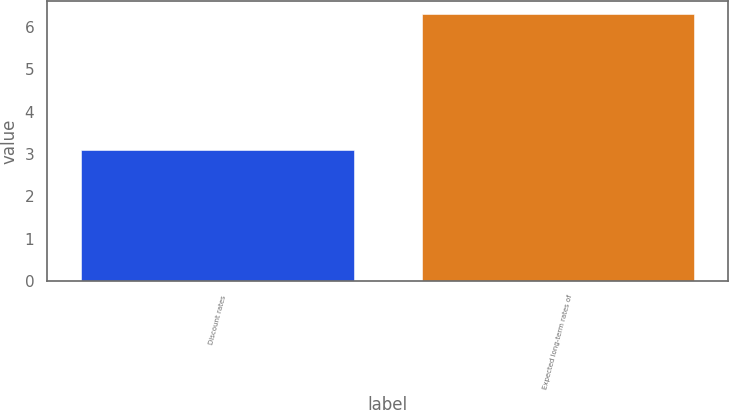Convert chart. <chart><loc_0><loc_0><loc_500><loc_500><bar_chart><fcel>Discount rates<fcel>Expected long-term rates of<nl><fcel>3.1<fcel>6.3<nl></chart> 